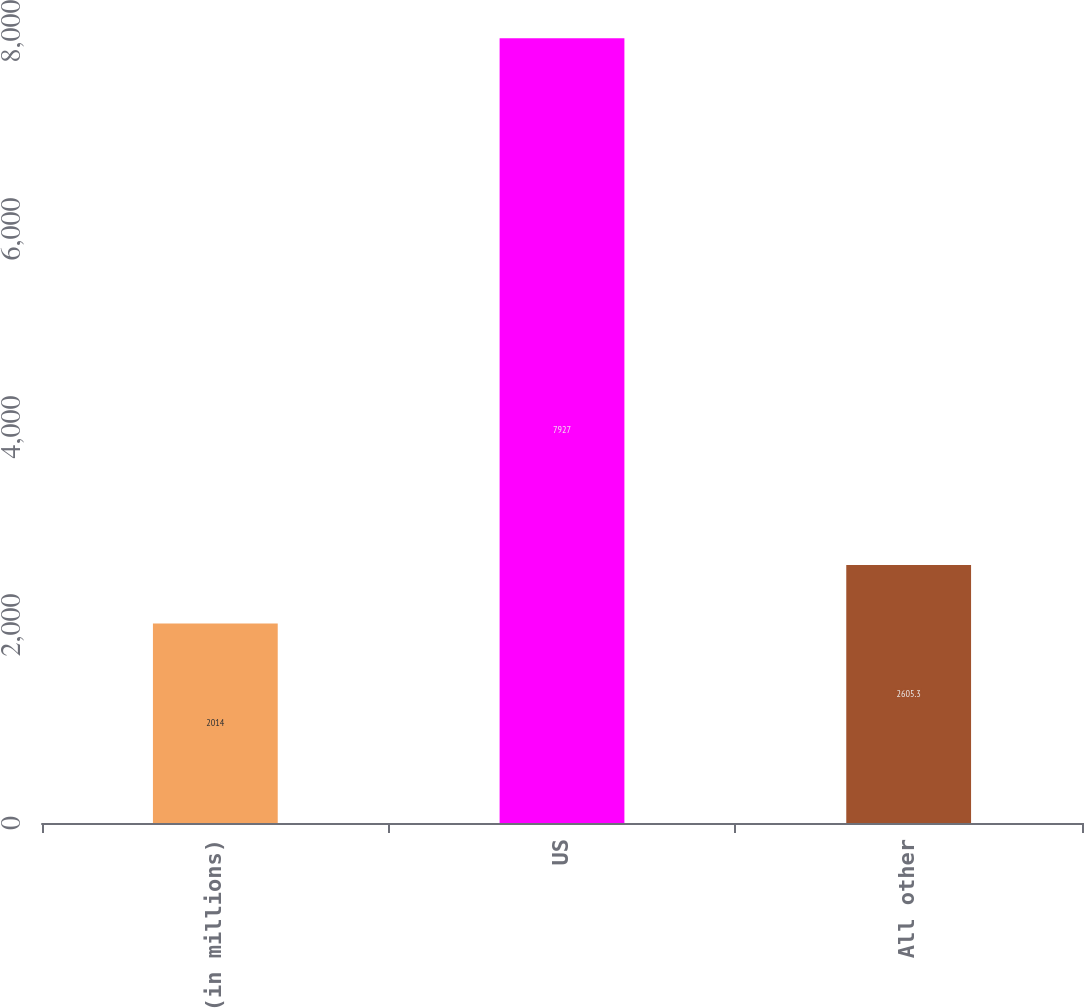<chart> <loc_0><loc_0><loc_500><loc_500><bar_chart><fcel>(in millions)<fcel>US<fcel>All other<nl><fcel>2014<fcel>7927<fcel>2605.3<nl></chart> 